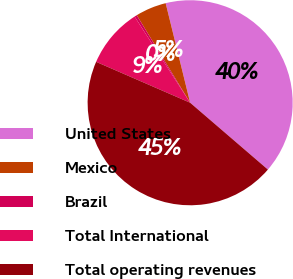Convert chart. <chart><loc_0><loc_0><loc_500><loc_500><pie_chart><fcel>United States<fcel>Mexico<fcel>Brazil<fcel>Total International<fcel>Total operating revenues<nl><fcel>40.14%<fcel>4.88%<fcel>0.39%<fcel>9.36%<fcel>45.23%<nl></chart> 